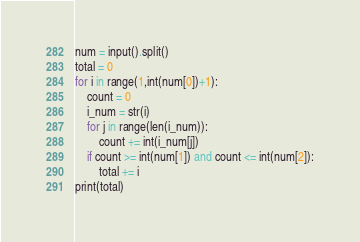Convert code to text. <code><loc_0><loc_0><loc_500><loc_500><_Python_>num = input().split()
total = 0
for i in range(1,int(num[0])+1):
    count = 0
    i_num = str(i)
    for j in range(len(i_num)):
        count += int(i_num[j])
    if count >= int(num[1]) and count <= int(num[2]):
        total += i
print(total)</code> 